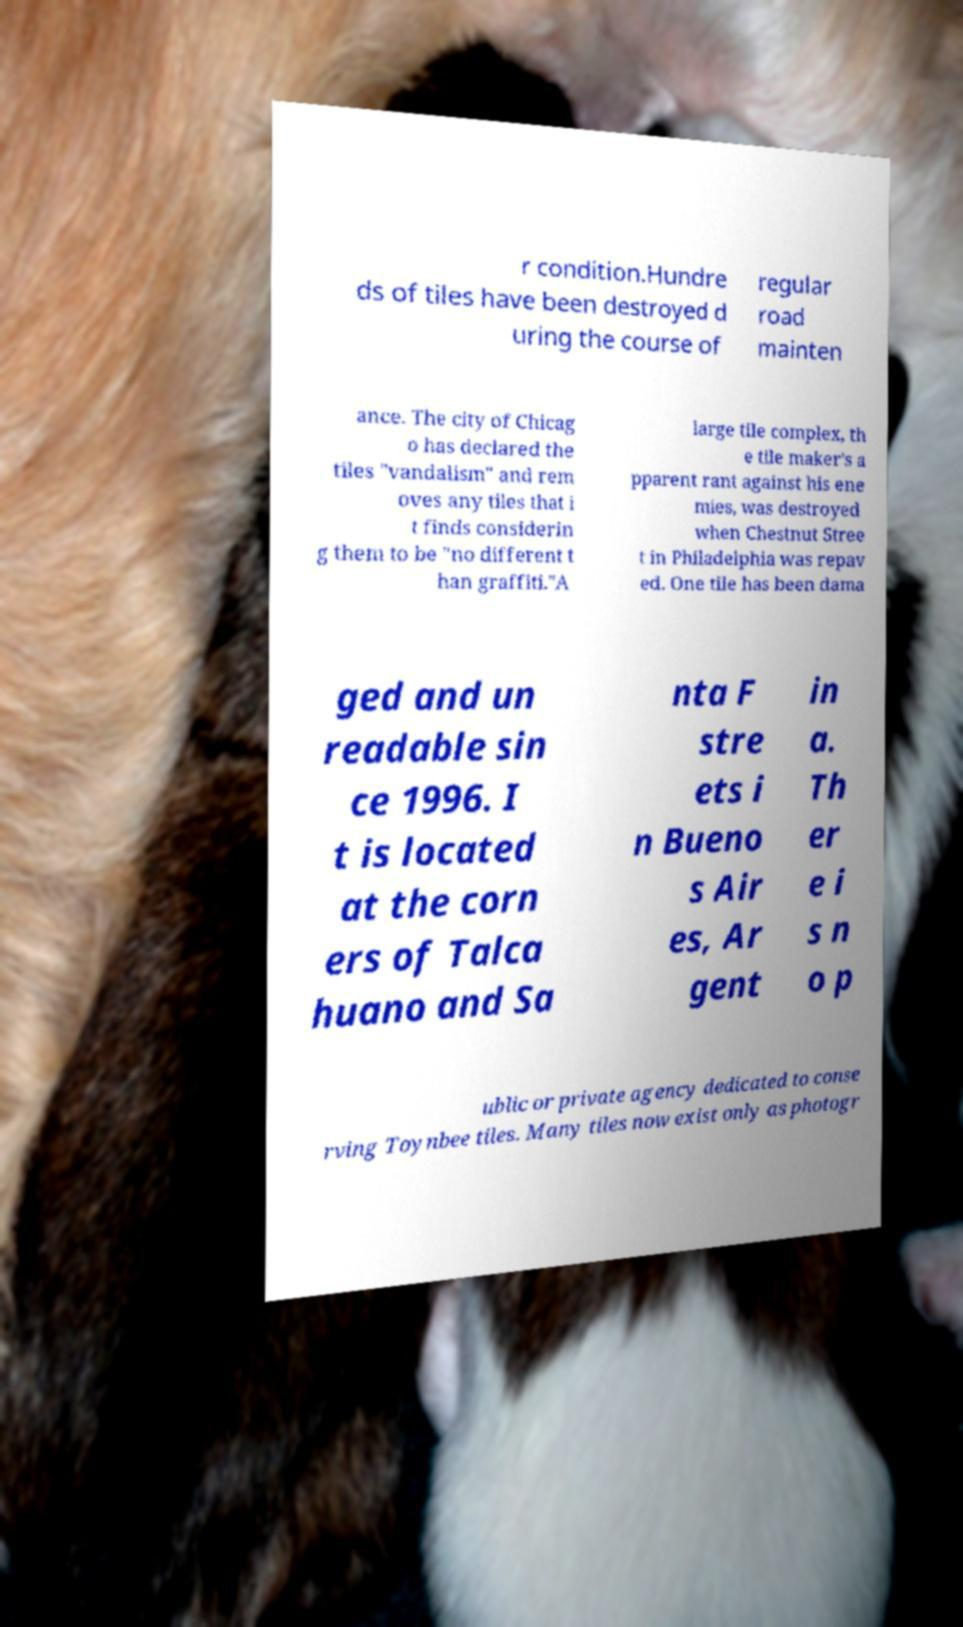For documentation purposes, I need the text within this image transcribed. Could you provide that? r condition.Hundre ds of tiles have been destroyed d uring the course of regular road mainten ance. The city of Chicag o has declared the tiles "vandalism" and rem oves any tiles that i t finds considerin g them to be "no different t han graffiti."A large tile complex, th e tile maker's a pparent rant against his ene mies, was destroyed when Chestnut Stree t in Philadelphia was repav ed. One tile has been dama ged and un readable sin ce 1996. I t is located at the corn ers of Talca huano and Sa nta F stre ets i n Bueno s Air es, Ar gent in a. Th er e i s n o p ublic or private agency dedicated to conse rving Toynbee tiles. Many tiles now exist only as photogr 